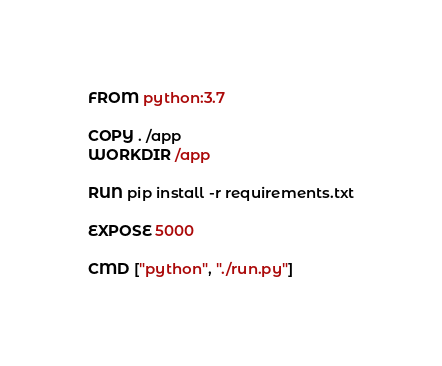Convert code to text. <code><loc_0><loc_0><loc_500><loc_500><_Dockerfile_>FROM python:3.7

COPY . /app
WORKDIR /app

RUN pip install -r requirements.txt

EXPOSE 5000

CMD ["python", "./run.py"]</code> 